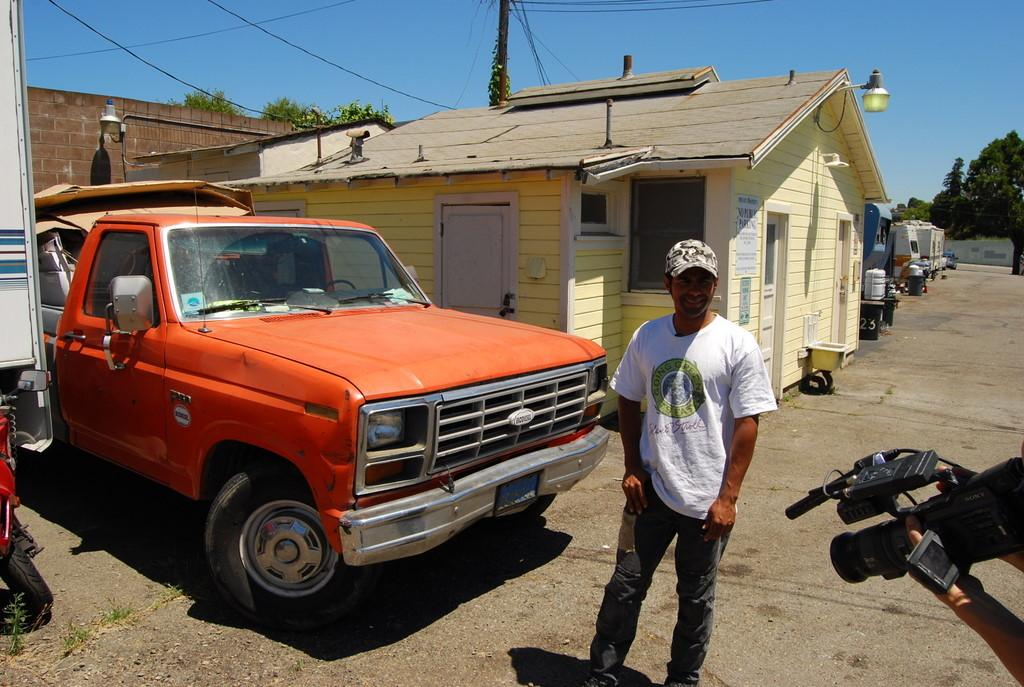What type of vehicle is in the image? There is a car in the image. What structure is visible in the image? There is a building in the image. Can you describe the person in the image? There is a person on the road in the image. What type of cloth is draped over the car in the image? There is no cloth draped over the car in the image. What color are the jeans worn by the person in the image? There is no information about the person's clothing in the image. 